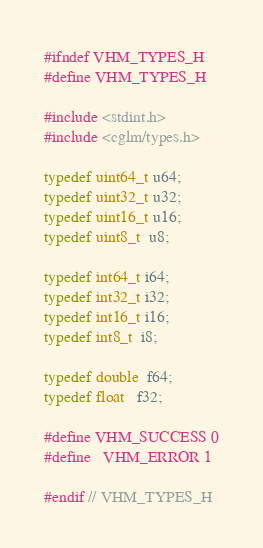Convert code to text. <code><loc_0><loc_0><loc_500><loc_500><_C_>#ifndef VHM_TYPES_H
#define VHM_TYPES_H

#include <stdint.h>
#include <cglm/types.h>

typedef uint64_t u64;
typedef uint32_t u32;
typedef uint16_t u16;
typedef uint8_t  u8;

typedef int64_t i64;
typedef int32_t i32;
typedef int16_t i16;
typedef int8_t  i8;

typedef double  f64;
typedef float   f32;

#define VHM_SUCCESS 0
#define   VHM_ERROR 1

#endif // VHM_TYPES_H</code> 